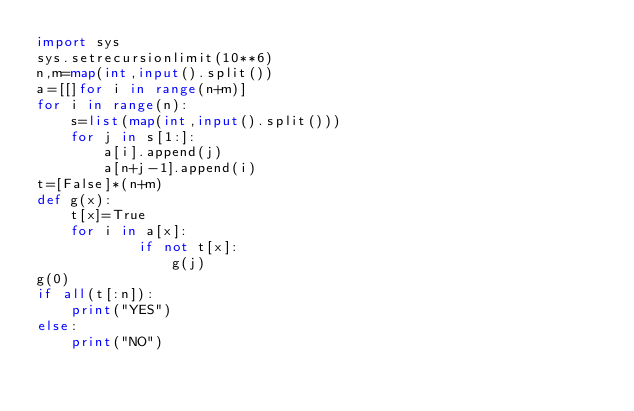Convert code to text. <code><loc_0><loc_0><loc_500><loc_500><_Python_>import sys
sys.setrecursionlimit(10**6)
n,m=map(int,input().split())
a=[[]for i in range(n+m)]
for i in range(n):
    s=list(map(int,input().split()))
    for j in s[1:]:
        a[i].append(j)
        a[n+j-1].append(i)
t=[False]*(n+m)
def g(x):
    t[x]=True
    for i in a[x]:
            if not t[x]:
                g(j)
g(0)
if all(t[:n]):
    print("YES")
else:
    print("NO")</code> 